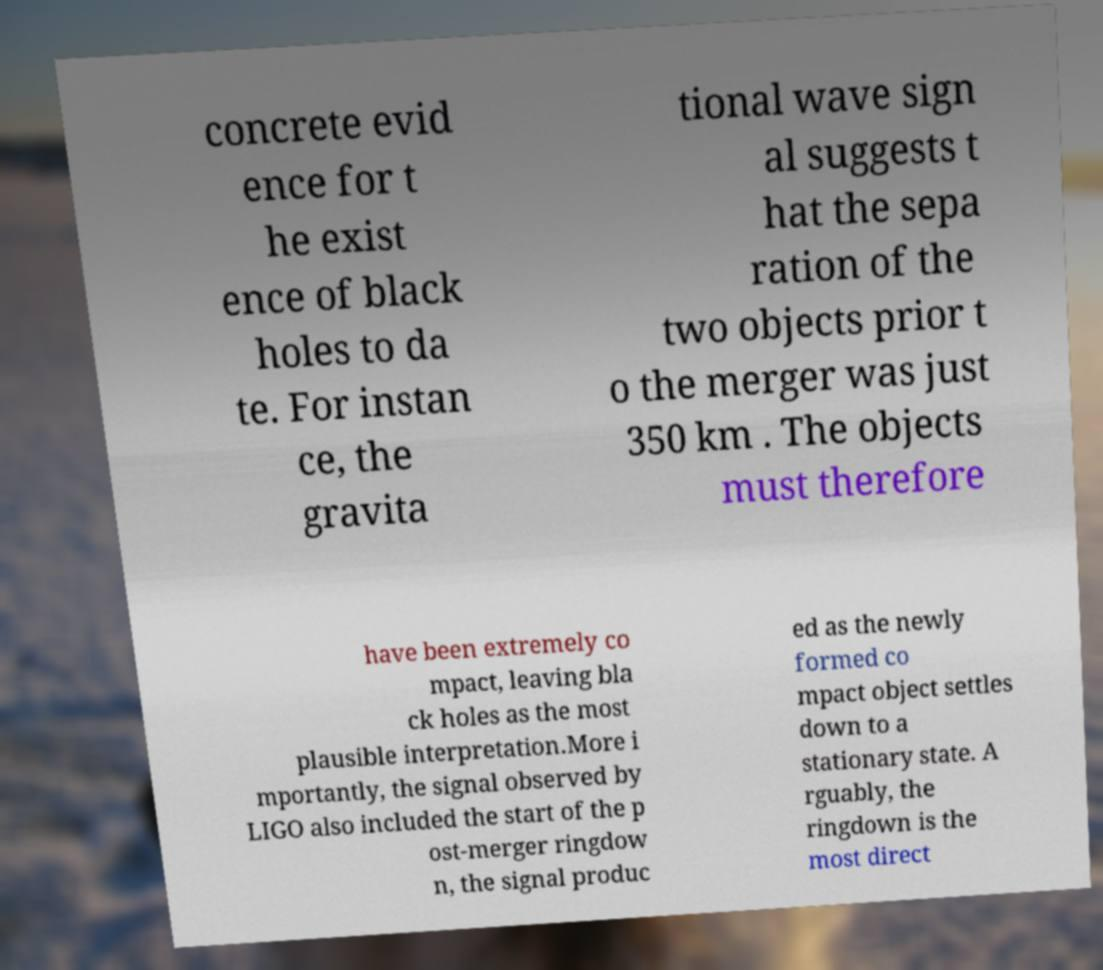I need the written content from this picture converted into text. Can you do that? concrete evid ence for t he exist ence of black holes to da te. For instan ce, the gravita tional wave sign al suggests t hat the sepa ration of the two objects prior t o the merger was just 350 km . The objects must therefore have been extremely co mpact, leaving bla ck holes as the most plausible interpretation.More i mportantly, the signal observed by LIGO also included the start of the p ost-merger ringdow n, the signal produc ed as the newly formed co mpact object settles down to a stationary state. A rguably, the ringdown is the most direct 